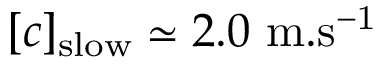<formula> <loc_0><loc_0><loc_500><loc_500>[ c ] _ { s l o w } \simeq 2 . 0 \ m . s ^ { - 1 }</formula> 